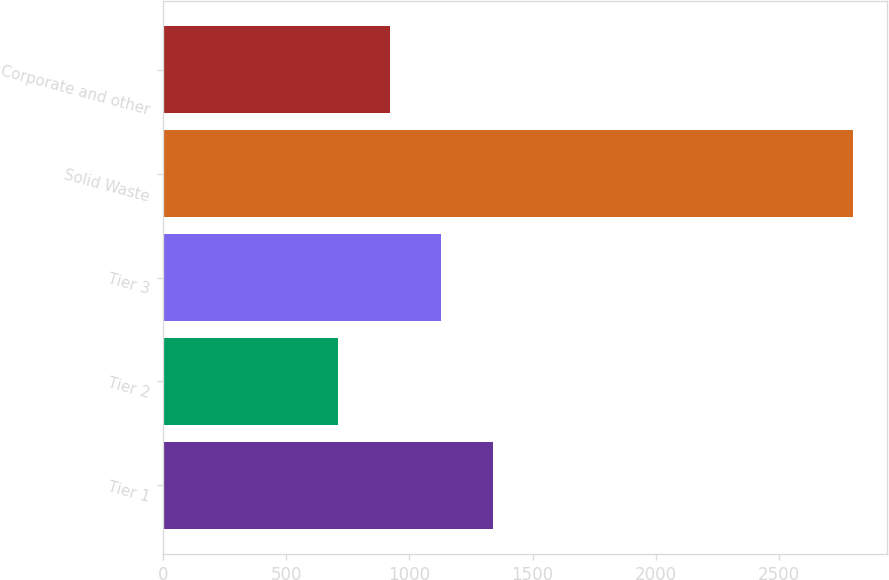Convert chart to OTSL. <chart><loc_0><loc_0><loc_500><loc_500><bar_chart><fcel>Tier 1<fcel>Tier 2<fcel>Tier 3<fcel>Solid Waste<fcel>Corporate and other<nl><fcel>1337.4<fcel>711<fcel>1128.6<fcel>2799<fcel>919.8<nl></chart> 